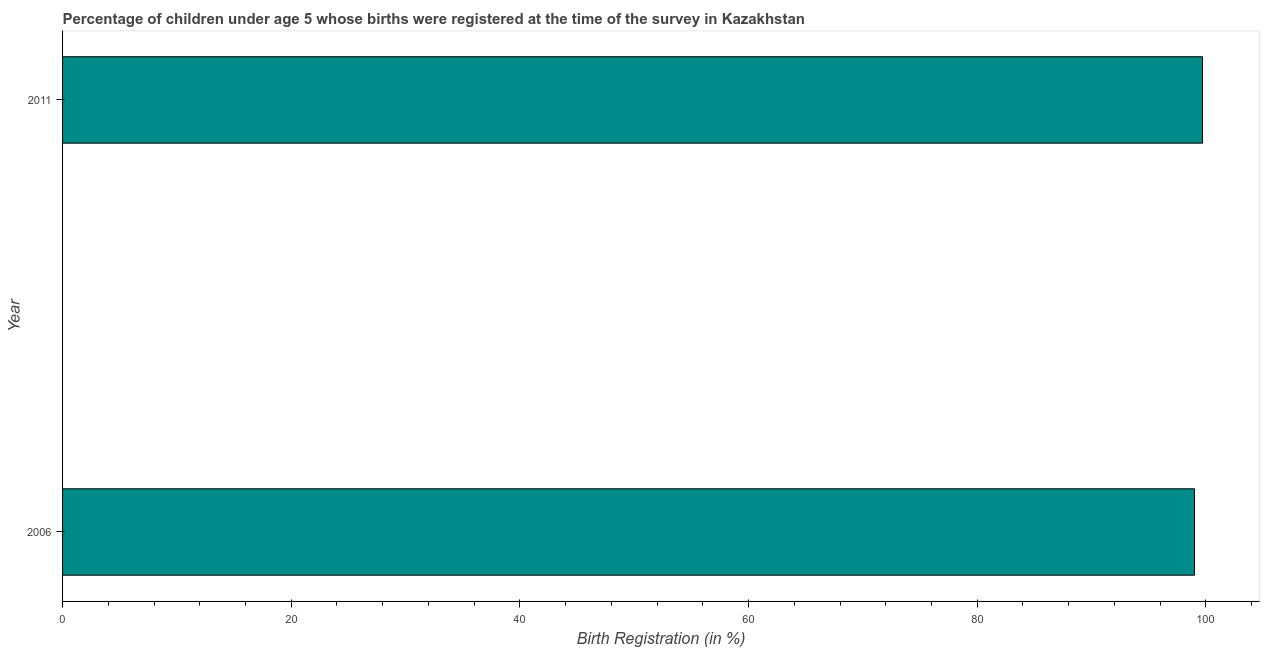Does the graph contain any zero values?
Your answer should be compact. No. Does the graph contain grids?
Keep it short and to the point. No. What is the title of the graph?
Ensure brevity in your answer.  Percentage of children under age 5 whose births were registered at the time of the survey in Kazakhstan. What is the label or title of the X-axis?
Provide a succinct answer. Birth Registration (in %). What is the label or title of the Y-axis?
Offer a very short reply. Year. What is the birth registration in 2011?
Give a very brief answer. 99.7. Across all years, what is the maximum birth registration?
Ensure brevity in your answer.  99.7. In which year was the birth registration maximum?
Keep it short and to the point. 2011. What is the sum of the birth registration?
Provide a succinct answer. 198.7. What is the average birth registration per year?
Your response must be concise. 99.35. What is the median birth registration?
Offer a very short reply. 99.35. In how many years, is the birth registration greater than 48 %?
Your answer should be very brief. 2. Do a majority of the years between 2011 and 2006 (inclusive) have birth registration greater than 96 %?
Offer a terse response. No. Is the birth registration in 2006 less than that in 2011?
Ensure brevity in your answer.  Yes. What is the difference between two consecutive major ticks on the X-axis?
Provide a short and direct response. 20. What is the Birth Registration (in %) in 2011?
Offer a very short reply. 99.7. What is the difference between the Birth Registration (in %) in 2006 and 2011?
Your response must be concise. -0.7. 